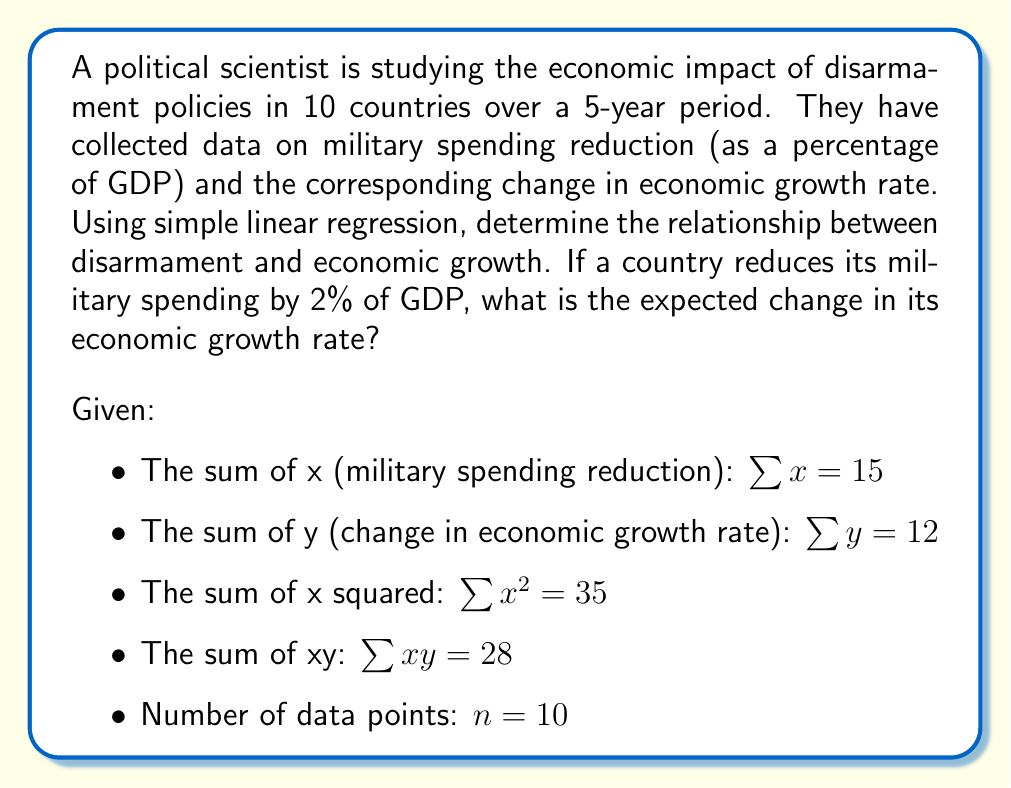Help me with this question. To solve this problem, we'll use simple linear regression to find the relationship between military spending reduction (x) and change in economic growth rate (y). We'll follow these steps:

1. Calculate the slope (b) of the regression line:
   $$b = \frac{n\sum xy - \sum x \sum y}{n\sum x^2 - (\sum x)^2}$$

2. Calculate the y-intercept (a):
   $$a = \frac{\sum y - b\sum x}{n}$$

3. Form the regression equation: $y = a + bx$

4. Use the equation to predict the change in economic growth rate for a 2% reduction in military spending.

Step 1: Calculate the slope (b)
$$b = \frac{10(28) - (15)(12)}{10(35) - (15)^2} = \frac{280 - 180}{350 - 225} = \frac{100}{125} = 0.8$$

Step 2: Calculate the y-intercept (a)
$$a = \frac{12 - 0.8(15)}{10} = \frac{12 - 12}{10} = 0$$

Step 3: Form the regression equation
$$y = 0 + 0.8x$$

Step 4: Predict the change in economic growth rate for a 2% reduction in military spending
$$y = 0 + 0.8(2) = 1.6$$

Therefore, if a country reduces its military spending by 2% of GDP, the expected change in its economic growth rate is an increase of 1.6 percentage points.
Answer: 1.6 percentage points increase 